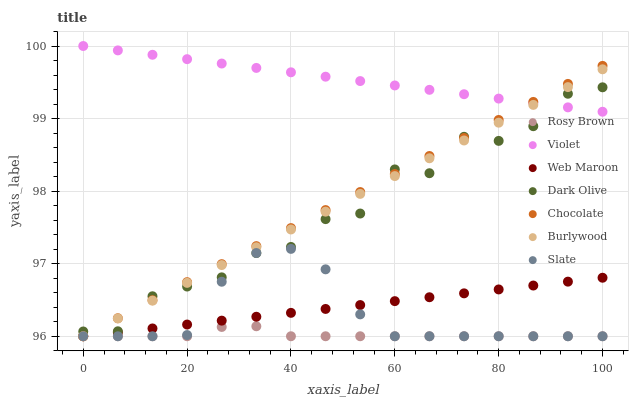Does Rosy Brown have the minimum area under the curve?
Answer yes or no. Yes. Does Violet have the maximum area under the curve?
Answer yes or no. Yes. Does Burlywood have the minimum area under the curve?
Answer yes or no. No. Does Burlywood have the maximum area under the curve?
Answer yes or no. No. Is Burlywood the smoothest?
Answer yes or no. Yes. Is Dark Olive the roughest?
Answer yes or no. Yes. Is Slate the smoothest?
Answer yes or no. No. Is Slate the roughest?
Answer yes or no. No. Does Rosy Brown have the lowest value?
Answer yes or no. Yes. Does Dark Olive have the lowest value?
Answer yes or no. No. Does Violet have the highest value?
Answer yes or no. Yes. Does Burlywood have the highest value?
Answer yes or no. No. Is Web Maroon less than Violet?
Answer yes or no. Yes. Is Violet greater than Rosy Brown?
Answer yes or no. Yes. Does Chocolate intersect Web Maroon?
Answer yes or no. Yes. Is Chocolate less than Web Maroon?
Answer yes or no. No. Is Chocolate greater than Web Maroon?
Answer yes or no. No. Does Web Maroon intersect Violet?
Answer yes or no. No. 